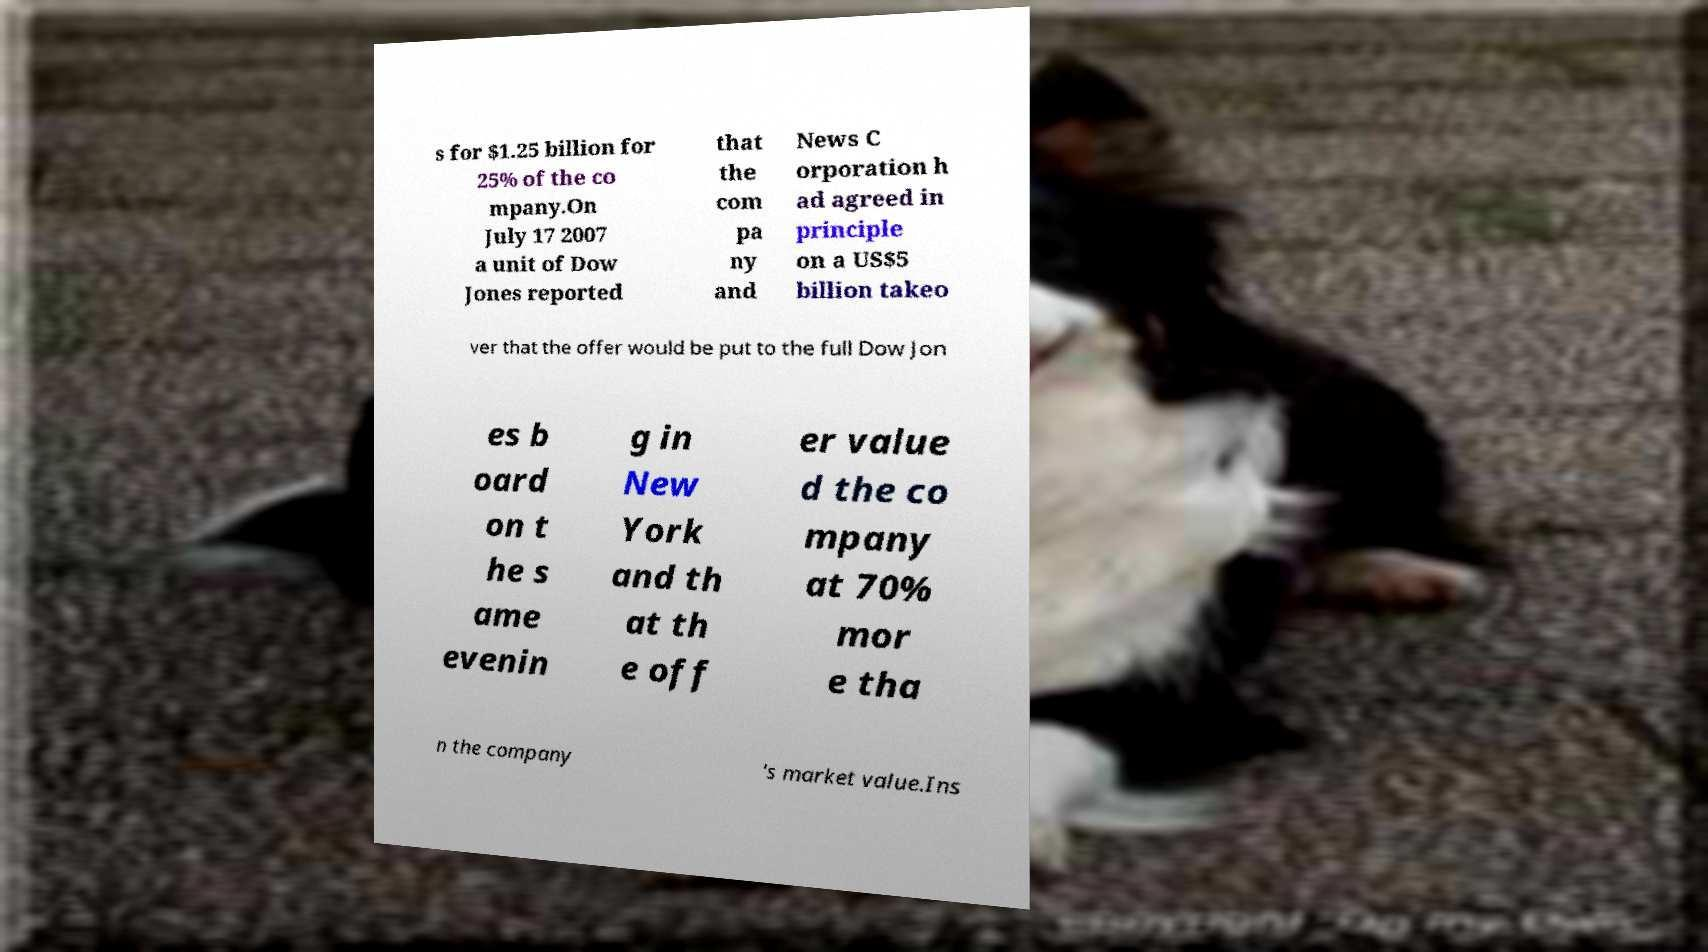Please identify and transcribe the text found in this image. s for $1.25 billion for 25% of the co mpany.On July 17 2007 a unit of Dow Jones reported that the com pa ny and News C orporation h ad agreed in principle on a US$5 billion takeo ver that the offer would be put to the full Dow Jon es b oard on t he s ame evenin g in New York and th at th e off er value d the co mpany at 70% mor e tha n the company 's market value.Ins 